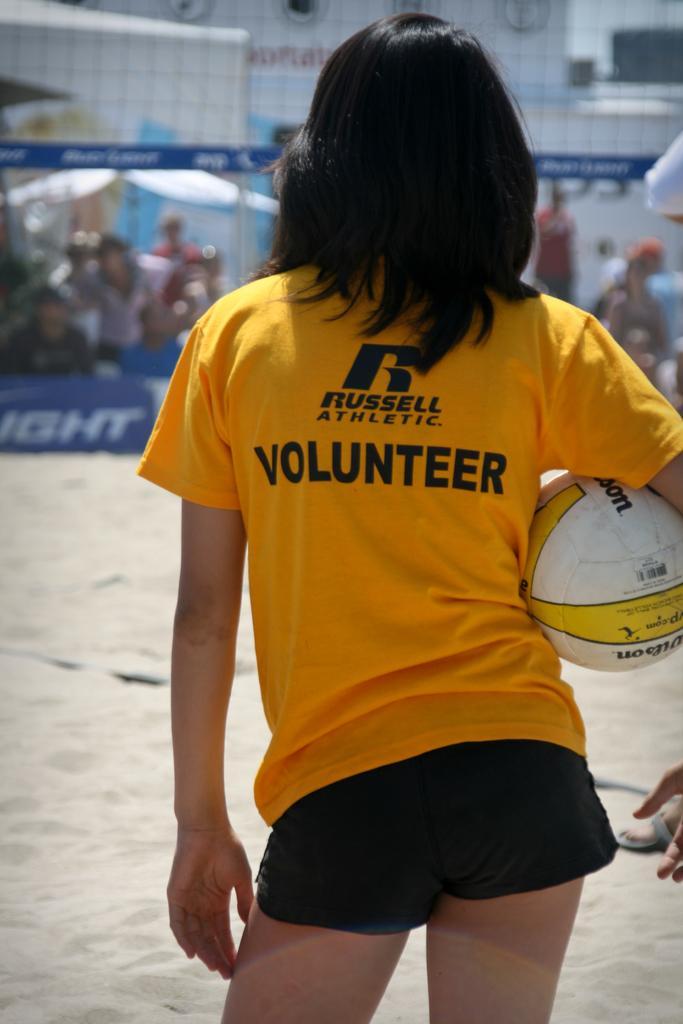In one or two sentences, can you explain what this image depicts? In this picture there is a person standing and holding a ball and in background there are some people 